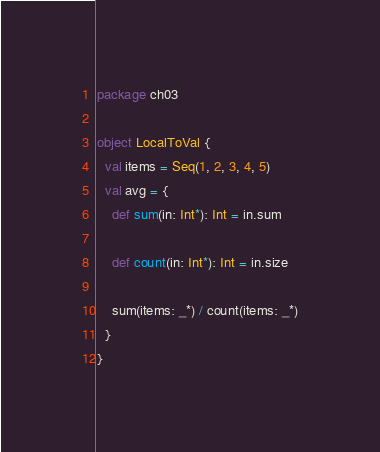<code> <loc_0><loc_0><loc_500><loc_500><_Scala_>package ch03

object LocalToVal {
  val items = Seq(1, 2, 3, 4, 5)
  val avg = {
    def sum(in: Int*): Int = in.sum

    def count(in: Int*): Int = in.size

    sum(items: _*) / count(items: _*)
  }
}
</code> 